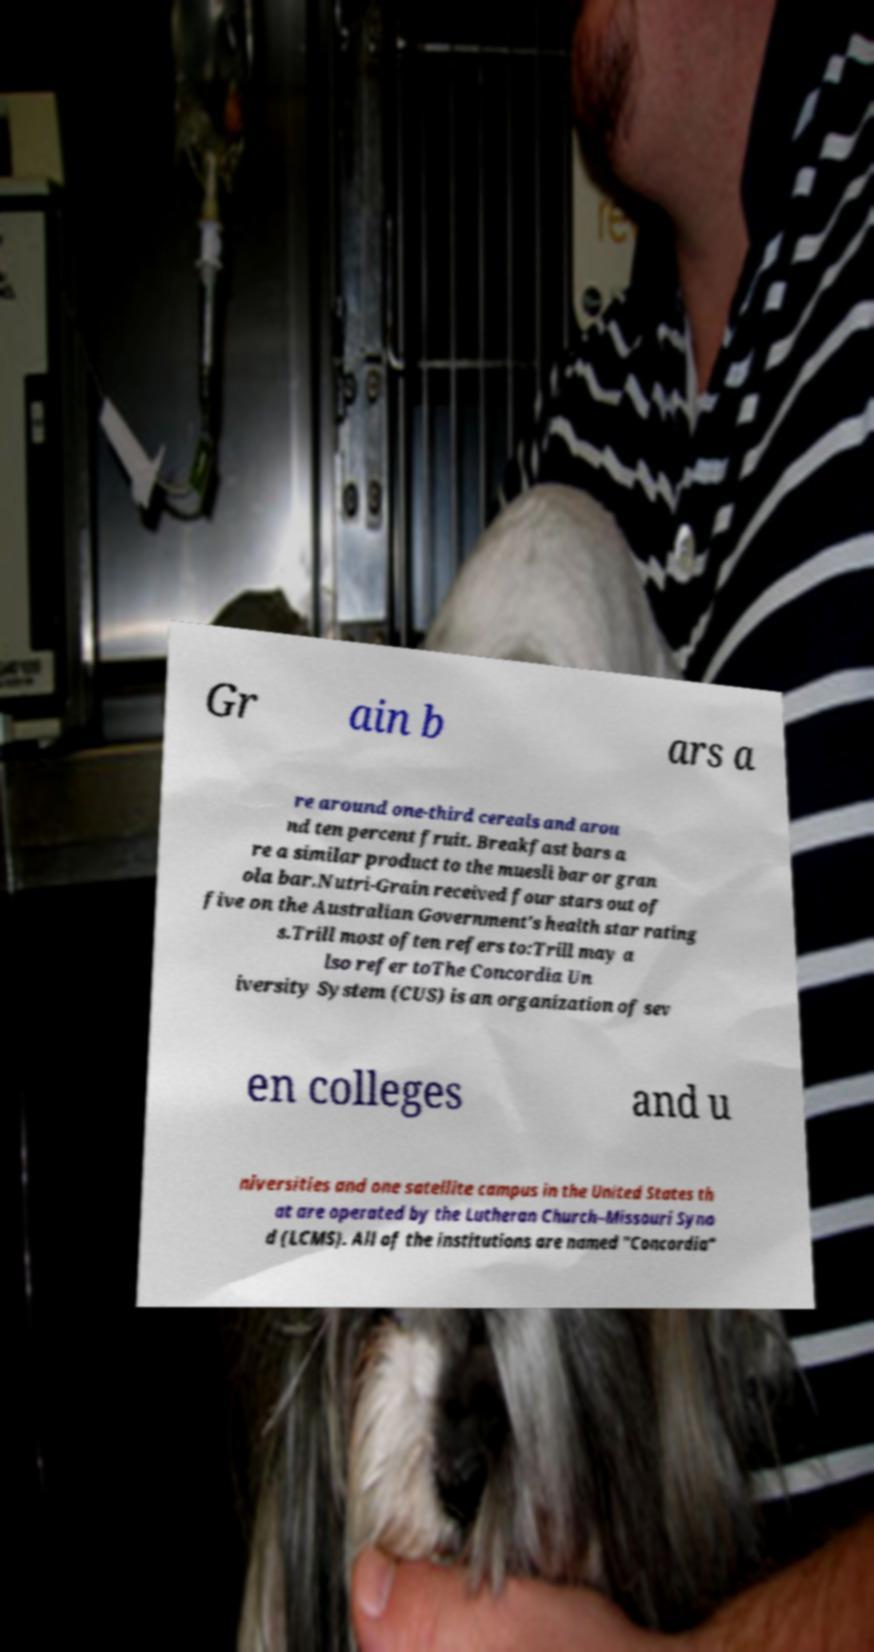Could you assist in decoding the text presented in this image and type it out clearly? Gr ain b ars a re around one-third cereals and arou nd ten percent fruit. Breakfast bars a re a similar product to the muesli bar or gran ola bar.Nutri-Grain received four stars out of five on the Australian Government's health star rating s.Trill most often refers to:Trill may a lso refer toThe Concordia Un iversity System (CUS) is an organization of sev en colleges and u niversities and one satellite campus in the United States th at are operated by the Lutheran Church–Missouri Syno d (LCMS). All of the institutions are named "Concordia" 